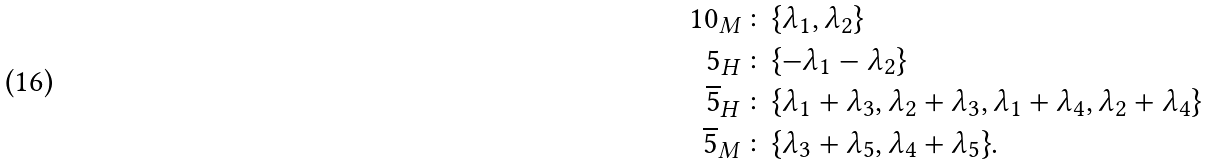Convert formula to latex. <formula><loc_0><loc_0><loc_500><loc_500>1 0 _ { M } & \colon \{ \lambda _ { 1 } , \lambda _ { 2 } \} \\ 5 _ { H } & \colon \{ - \lambda _ { 1 } - \lambda _ { 2 } \} \\ \overline { 5 } _ { H } & \colon \{ \lambda _ { 1 } + \lambda _ { 3 } , \lambda _ { 2 } + \lambda _ { 3 } , \lambda _ { 1 } + \lambda _ { 4 } , \lambda _ { 2 } + \lambda _ { 4 } \} \\ \overline { 5 } _ { M } & \colon \{ \lambda _ { 3 } + \lambda _ { 5 } , \lambda _ { 4 } + \lambda _ { 5 } \} .</formula> 